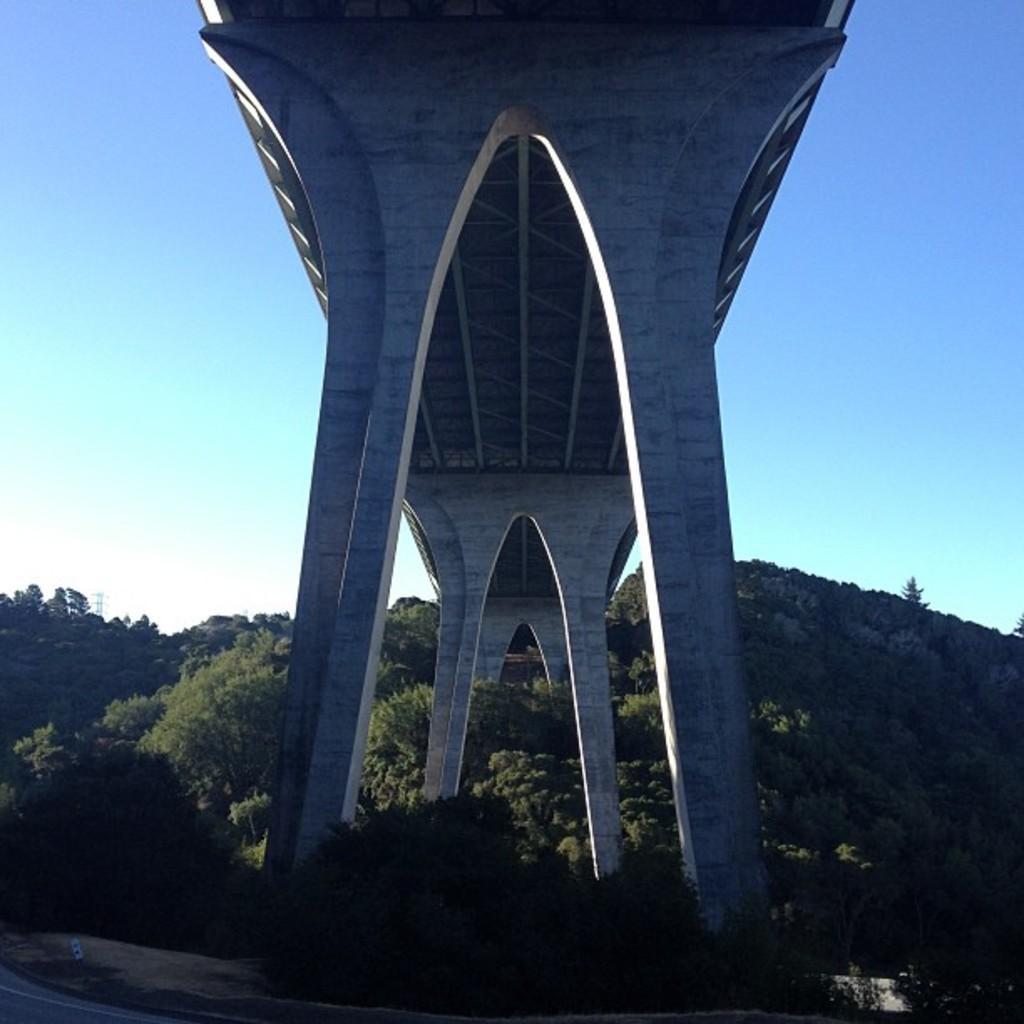Could you give a brief overview of what you see in this image? In this picture we can see a bridge, in the background there are some trees, we can see pillars in the front, there is the sky at the top of the picture. 